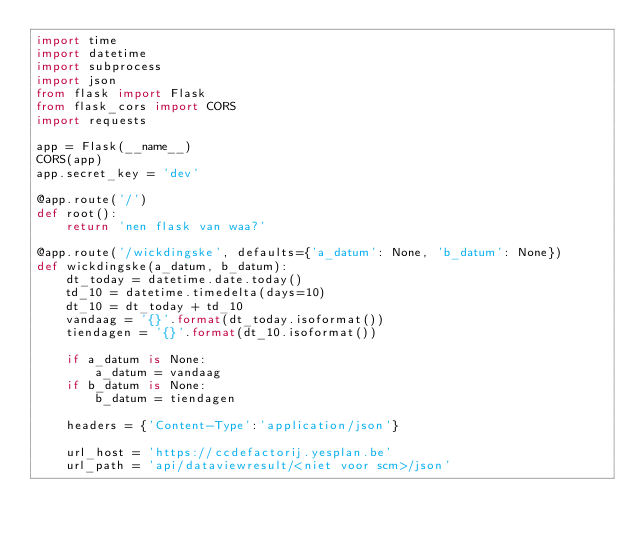Convert code to text. <code><loc_0><loc_0><loc_500><loc_500><_Python_>import time
import datetime
import subprocess
import json
from flask import Flask
from flask_cors import CORS
import requests

app = Flask(__name__)
CORS(app)
app.secret_key = 'dev'

@app.route('/')
def root():
    return 'nen flask van waa?'

@app.route('/wickdingske', defaults={'a_datum': None, 'b_datum': None})
def wickdingske(a_datum, b_datum):
    dt_today = datetime.date.today()
    td_10 = datetime.timedelta(days=10)
    dt_10 = dt_today + td_10
    vandaag = '{}'.format(dt_today.isoformat())
    tiendagen = '{}'.format(dt_10.isoformat())

    if a_datum is None:
        a_datum = vandaag
    if b_datum is None:
        b_datum = tiendagen

    headers = {'Content-Type':'application/json'}

    url_host = 'https://ccdefactorij.yesplan.be'
    url_path = 'api/dataviewresult/<niet voor scm>/json'</code> 